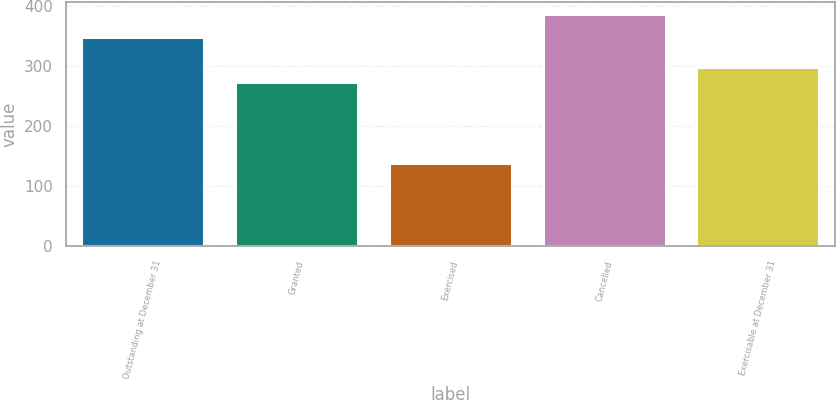Convert chart to OTSL. <chart><loc_0><loc_0><loc_500><loc_500><bar_chart><fcel>Outstanding at December 31<fcel>Granted<fcel>Exercised<fcel>Cancelled<fcel>Exercisable at December 31<nl><fcel>347.4<fcel>273<fcel>139<fcel>387<fcel>297.8<nl></chart> 